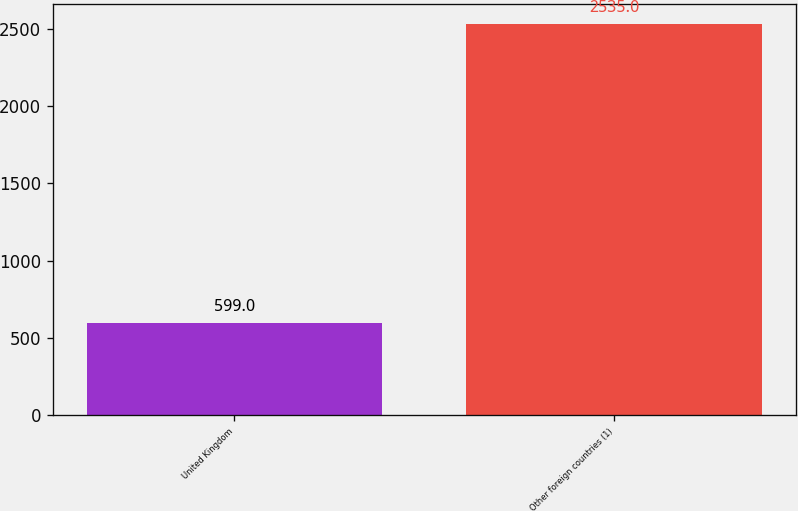<chart> <loc_0><loc_0><loc_500><loc_500><bar_chart><fcel>United Kingdom<fcel>Other foreign countries (1)<nl><fcel>599<fcel>2535<nl></chart> 